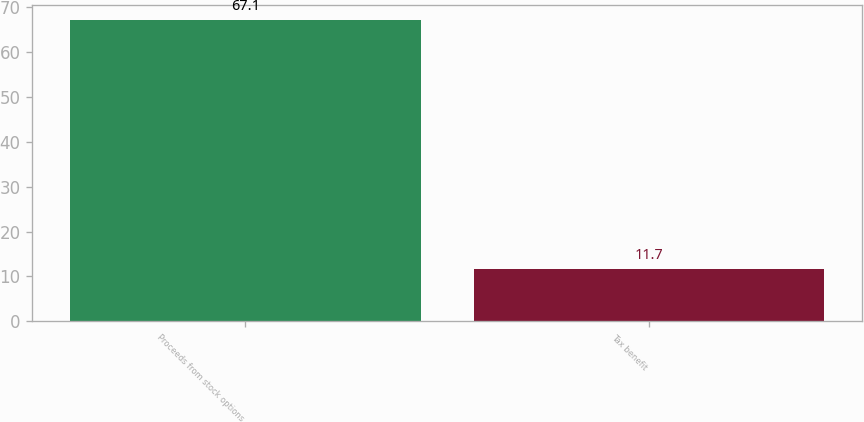<chart> <loc_0><loc_0><loc_500><loc_500><bar_chart><fcel>Proceeds from stock options<fcel>Tax benefit<nl><fcel>67.1<fcel>11.7<nl></chart> 